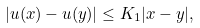Convert formula to latex. <formula><loc_0><loc_0><loc_500><loc_500>| u ( x ) - u ( y ) | \leq K _ { 1 } | x - y | ,</formula> 